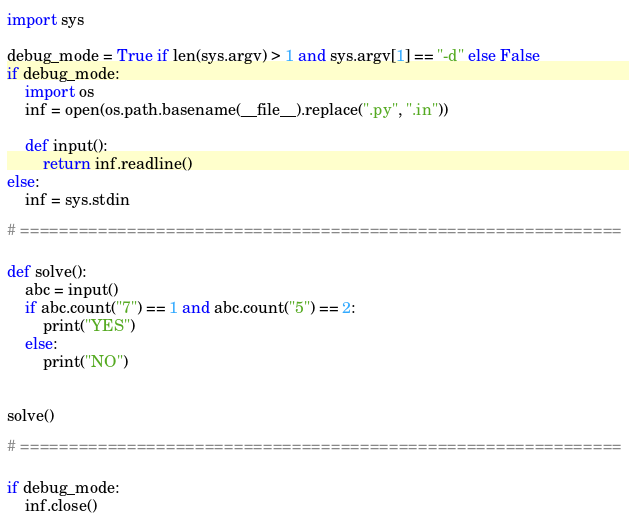Convert code to text. <code><loc_0><loc_0><loc_500><loc_500><_Python_>import sys

debug_mode = True if len(sys.argv) > 1 and sys.argv[1] == "-d" else False
if debug_mode:
    import os
    inf = open(os.path.basename(__file__).replace(".py", ".in"))

    def input():
        return inf.readline()
else:
    inf = sys.stdin

# ==============================================================

def solve():
    abc = input()
    if abc.count("7") == 1 and abc.count("5") == 2:
        print("YES")
    else:
        print("NO")


solve()

# ==============================================================

if debug_mode:
    inf.close()
</code> 